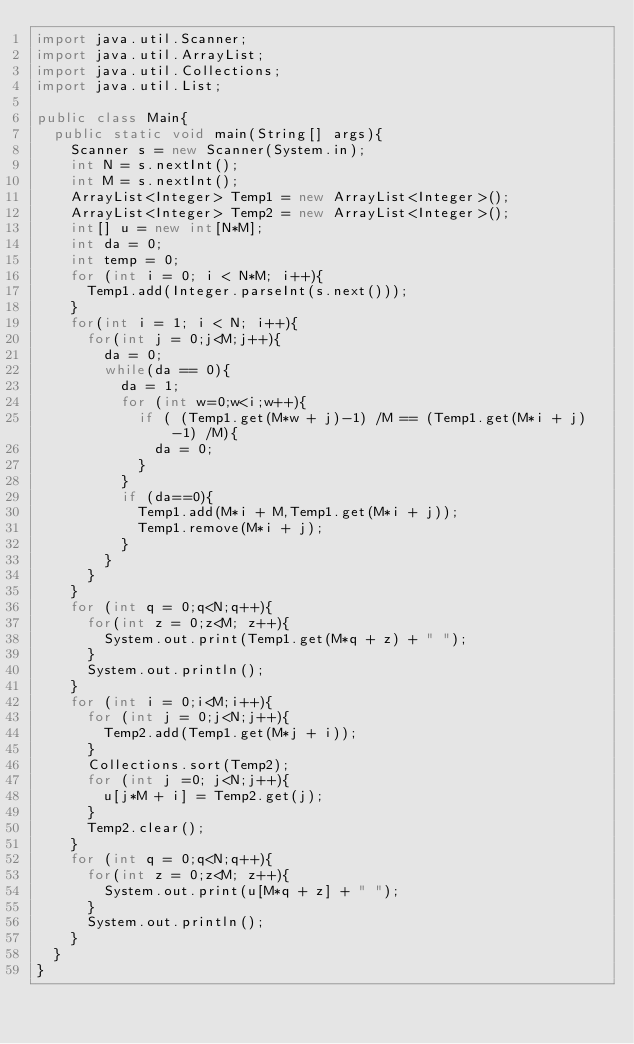Convert code to text. <code><loc_0><loc_0><loc_500><loc_500><_Java_>import java.util.Scanner;
import java.util.ArrayList;
import java.util.Collections;
import java.util.List;
 
public class Main{
  public static void main(String[] args){
    Scanner s = new Scanner(System.in);
    int N = s.nextInt();
    int M = s.nextInt();
    ArrayList<Integer> Temp1 = new ArrayList<Integer>();
    ArrayList<Integer> Temp2 = new ArrayList<Integer>();
    int[] u = new int[N*M];
    int da = 0;
    int temp = 0;
    for (int i = 0; i < N*M; i++){
      Temp1.add(Integer.parseInt(s.next()));
    }
    for(int i = 1; i < N; i++){
      for(int j = 0;j<M;j++){
        da = 0;
        while(da == 0){
          da = 1;
          for (int w=0;w<i;w++){
            if ( (Temp1.get(M*w + j)-1) /M == (Temp1.get(M*i + j)-1) /M){
              da = 0;
            }
          }
          if (da==0){
            Temp1.add(M*i + M,Temp1.get(M*i + j));
            Temp1.remove(M*i + j);
          }
        }
      }
    }
    for (int q = 0;q<N;q++){
      for(int z = 0;z<M; z++){
        System.out.print(Temp1.get(M*q + z) + " ");
      }
      System.out.println();
    }
    for (int i = 0;i<M;i++){
      for (int j = 0;j<N;j++){
        Temp2.add(Temp1.get(M*j + i));
      }
      Collections.sort(Temp2);
      for (int j =0; j<N;j++){
        u[j*M + i] = Temp2.get(j);
      }
      Temp2.clear();
    }
    for (int q = 0;q<N;q++){
      for(int z = 0;z<M; z++){
        System.out.print(u[M*q + z] + " ");
      }
      System.out.println();
    }
  }
}</code> 